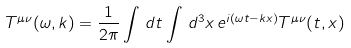<formula> <loc_0><loc_0><loc_500><loc_500>T ^ { \mu \nu } ( \omega , k ) = \frac { 1 } { 2 \pi } \int \, d t \int \, d ^ { 3 } x \, e ^ { i ( \omega t - k x ) } T ^ { \mu \nu } ( t , x )</formula> 